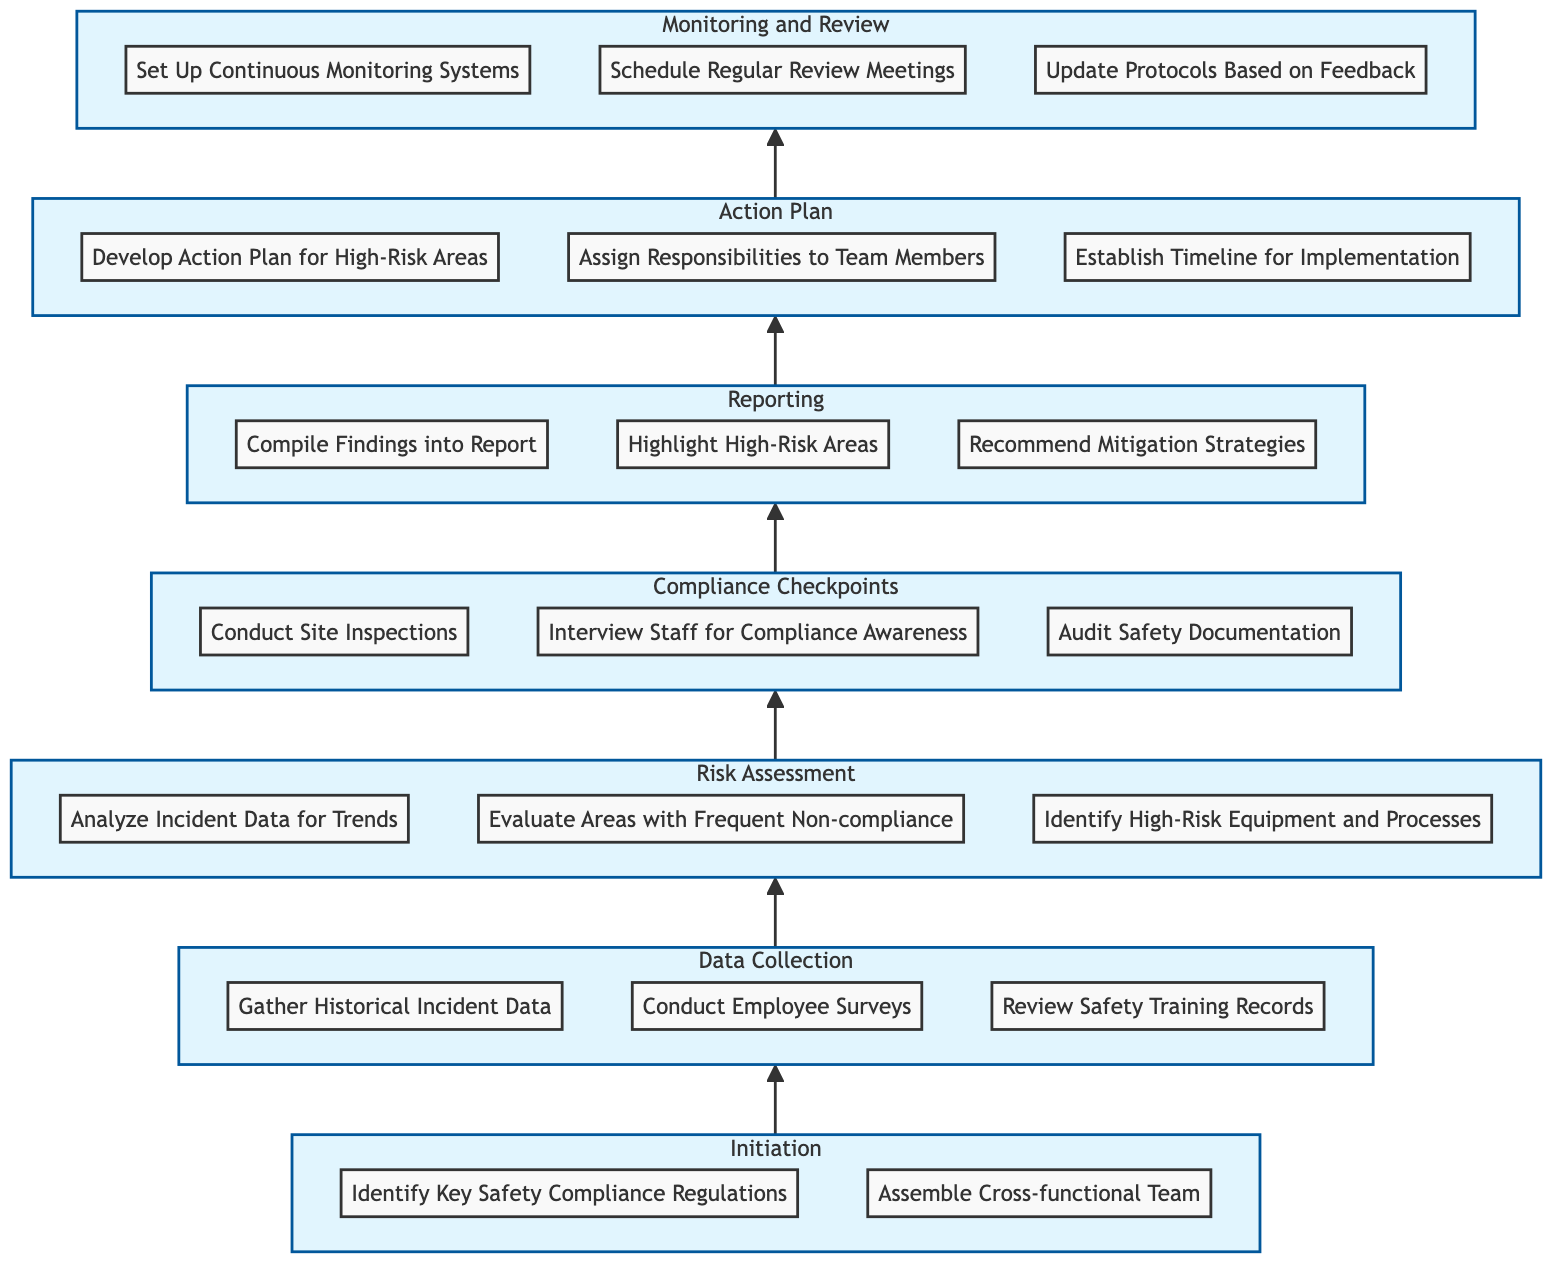What is the first level in the flow chart? The flow chart starts with the level titled "Initiation," which contains the first set of actions related to assessing safety compliance.
Answer: Initiation How many elements are in the "Risk Assessment" level? The "Risk Assessment" level contains three elements: Analyze Incident Data for Trends, Evaluate Areas with Frequent Non-compliance, and Identify High-Risk Equipment and Processes. Thus, the total count is three.
Answer: 3 What action follows "Conduct Site Inspections"? "Conduct Site Inspections" is part of the "Compliance Checkpoints" level and leads directly into the "Reporting" level, specifically to "Compile Findings into Report."
Answer: Compile Findings into Report Which level includes the action "Set Up Continuous Monitoring Systems"? "Set Up Continuous Monitoring Systems" is an action found in the last level of the diagram, which is titled "Monitoring and Review."
Answer: Monitoring and Review What are the three primary actions under the "Data Collection" level? The three primary actions in the "Data Collection" level are Gather Historical Incident Data, Conduct Employee Surveys, and Review Safety Training Records, which collectively inform the risk assessment process.
Answer: Gather Historical Incident Data, Conduct Employee Surveys, Review Safety Training Records What is the last step in the flow chart? The final step in the flow chart is "Update Protocols Based on Feedback," which is part of the last level, "Monitoring and Review." This indicates ongoing improvement based on collected insights.
Answer: Update Protocols Based on Feedback Which element is associated with both the "Risk Assessment" and "Compliance Checkpoints" levels? The element "Evaluate Areas with Frequent Non-compliance" relates to the assessment of risk and is crucial for planning compliance checks, showing a connection between these two levels of the diagram.
Answer: Evaluate Areas with Frequent Non-compliance What is the total number of levels in the flow chart? The flow chart consists of seven distinct levels, each representing a stage in assessing high-risk areas in safety compliance protocols from initiation to monitoring and review.
Answer: 7 